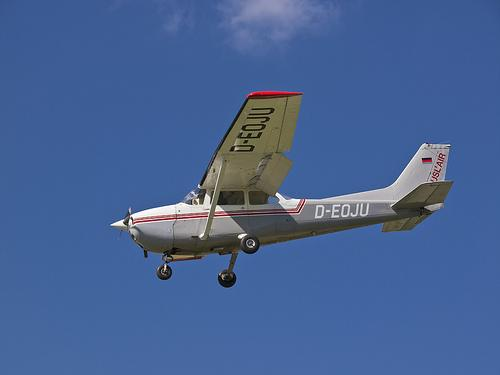Provide a brief description of the main object in the image along with its environment. A grey, red, and white airplane is flying in a clear blue sky with a few wispy clouds around it. Give a short explanation of what's happening in the image. In the image, a grey, red, and white airplane can be seen flying through a clear blue sky, with a few clouds as a backdrop and notable details like wheels and propellers. Write an opening sentence for a story using the image as a prompt. As Amelia looked up into the vast blue sky, admiring the clouds that only seemed to softly touch the edges of the grey, red, and white airplane, she couldn't help but dream about the adventures that awaited her far above. Mention the key elements in the image, including the background and specific details. The image features a grey, red, and white airplane in the sky, with details like propellers, wheels, and lettering on the wings; the background is a clear blue sky with a few clouds. Express your thoughts about the contents of the image. I find the image of the grey, red, and white airplane flying in the clear blue sky with a few clouds surrounding it quite fascinating, especially with the attention to details like the wheels, propellers, and lettering on the wings. Narrate what you see in the image as a news headline. "Small Airplane Soars High in Clear Blue Skies with Its Details in Full Display!" Transform the image into a generated message or tweet. 🛩️ In awe of this grey, red, and white airplane flying high in the crystal blue sky with wispy clouds! Love the attention to details like the propellers, wheels, and letters! ✈️☁️ #Aviation #Airplane #Sky Express what you see in the image in a poetic manner. Soaring gracefully above with hues of grey, red, and white, an airplane embraces the limitless blue sky, as whispers of clouds grace the heavens nearby. Write a concise summary of the image. Grey, red, and white airplane in a clear blue sky with some clouds, featuring details like wheels, propellers, and letters on wings. Describe the main subject, its colors, and the surrounding environment in the image. The image depicts a grey, red, and white airplane flying in a vivid blue sky with some scattered clouds, featuring propellers, wheels, and lettering on the wings. 